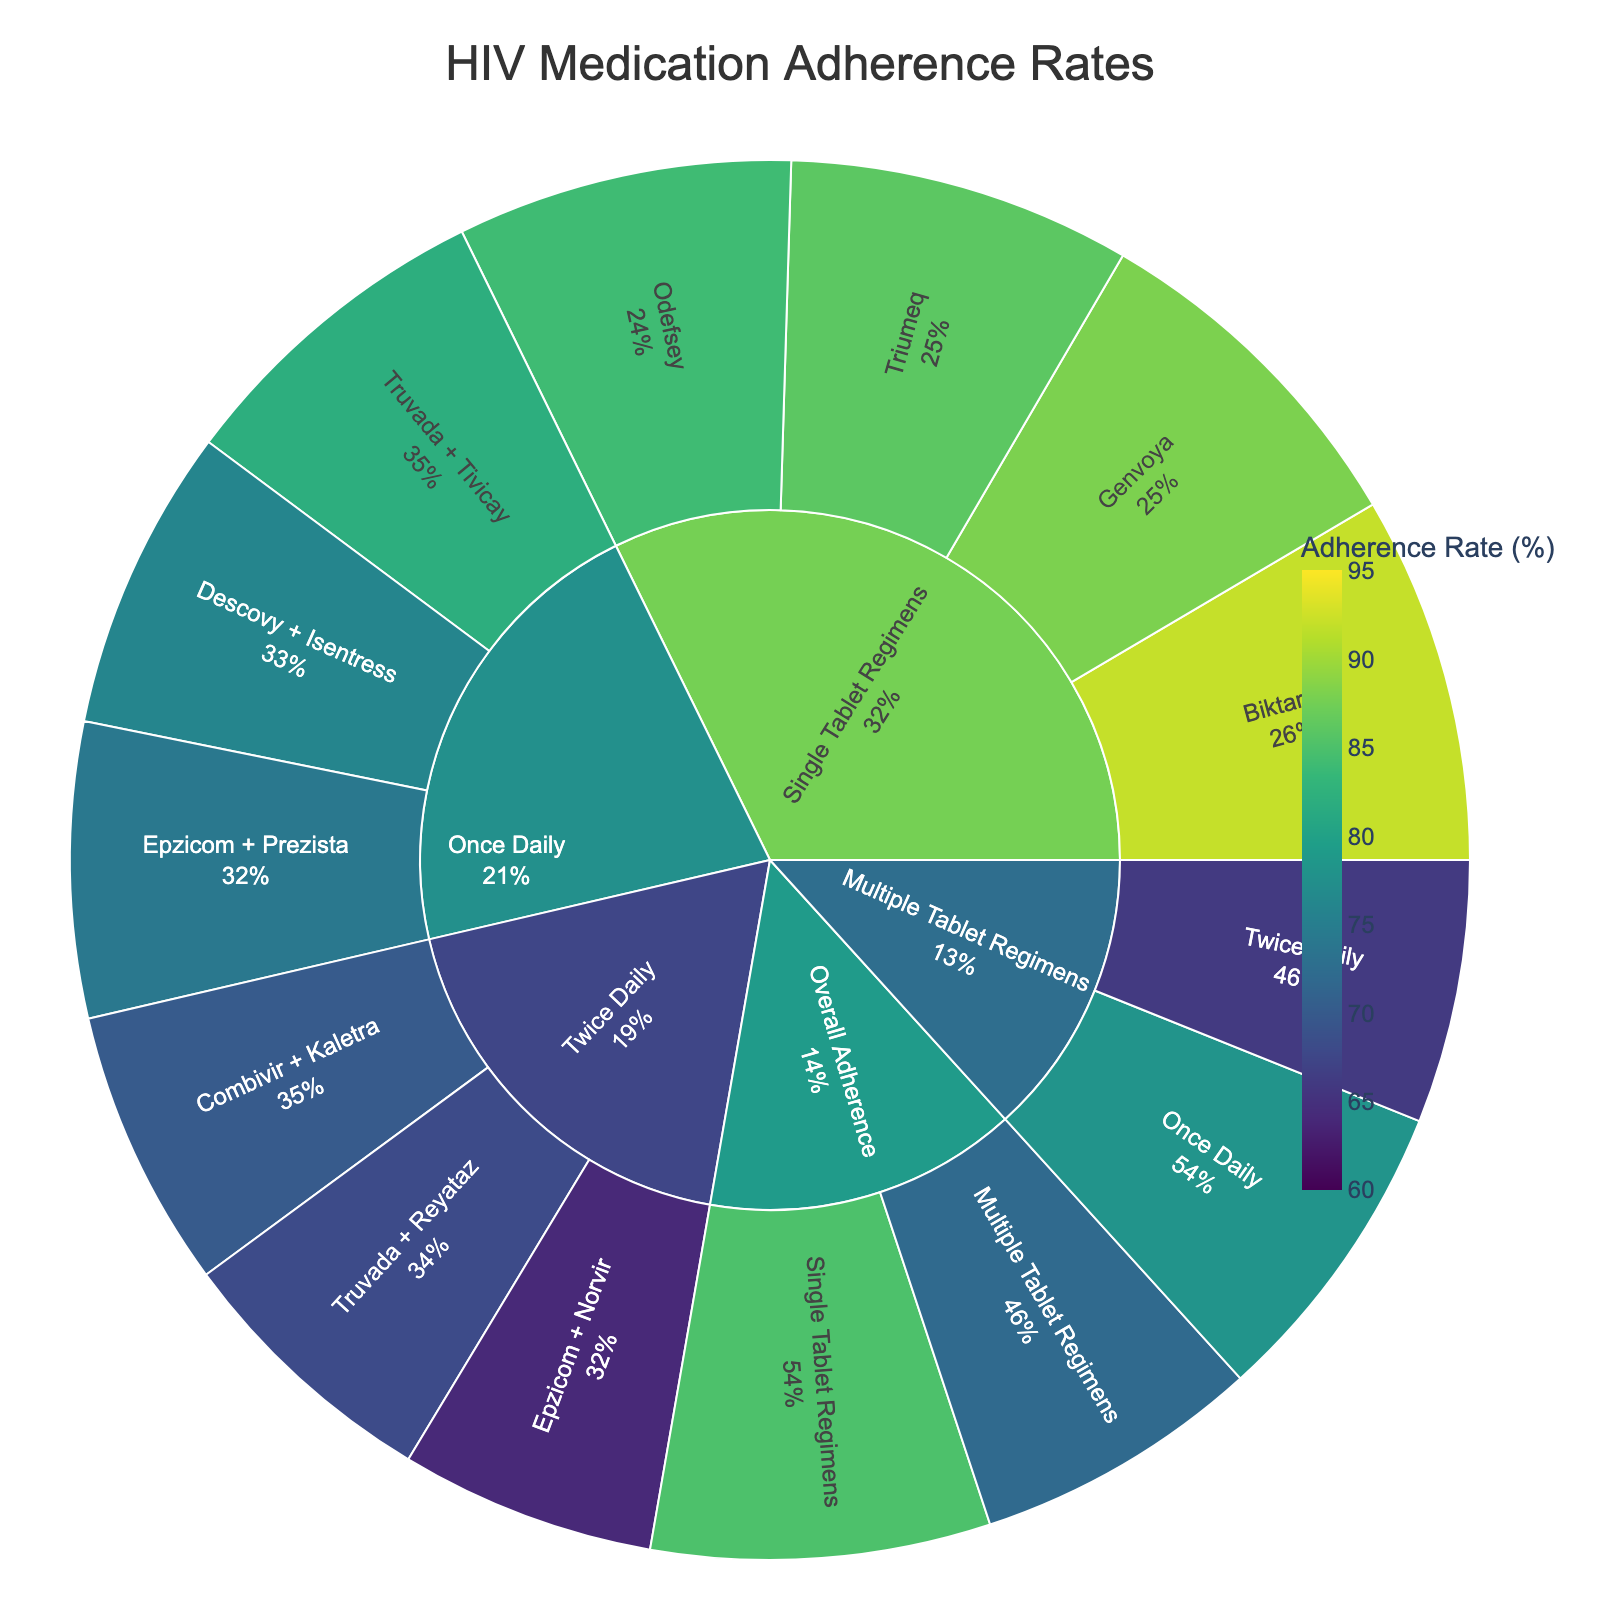What is the adherence rate for Single Tablet Regimens? The adherence rate for Single Tablet Regimens is shown directly within the category labeled "Single Tablet Regimens."
Answer: 85% Which drug under Single Tablet Regimens has the highest adherence rate? Under Single Tablet Regimens, the drug Biktarvy shows the highest percentage value at 92%.
Answer: Biktarvy Which group has a higher overall adherence rate, Single Tablet Regimens or Multiple Tablet Regimens? By looking at the adherence rates for Single Tablet Regimens (85%) and Multiple Tablet Regimens (72%), we see that Single Tablet Regimens have a higher overall adherence rate.
Answer: Single Tablet Regimens What is the adherence rate for Truvada + Tivicay under Once Daily? Truvada + Tivicay under Once Daily is located within the "Once Daily" subcategory, and the adherence rate for this combination is labeled as 82%.
Answer: 82% What is the sum of adherence rates for Once Daily regimens? Summing the adherence rates for Once Daily regimens: Truvada + Tivicay (82%), Descovy + Isentress (76%), Epzicom + Prezista (74%) results in 82 + 76 + 74 = 232.
Answer: 232% Which dosage frequency under Multiple Tablets Regimens has a lower adherence rate, Once Daily or Twice Daily? Comparing the adherence rates for Once Daily (78%) and Twice Daily (66%) under Multiple Tablets Regimens, Twice Daily has a lower adherence rate.
Answer: Twice Daily What is the difference in adherence rates between Triumeq and Odefsey under Single Tablet Regimens? Adherence rates for Triumeq and Odefsey are 86% and 84% respectively, so the difference is 86% - 84% = 2%.
Answer: 2% What percentage of the overall adherence rate does Genvoya contribute to Single Tablet Regimens? Genvoya has an adherence rate of 88%. Given that Single Tablet Regimens have an overall adherence rate of 85%, Genvoya's share within Single Tablet Regimens is calculated as (88 / 85) * 100 = 103.53%.
Answer: 103.53% Are all adherence rates for twice-daily Multiple Tablet Regimens lower than those for once-daily regimens? By comparing the adherence rates, Twice Daily regimens have rates of 70%, 68%, and 64%. The Once Daily rates are 82%, 76%, and 74%. All Twice Daily rates are indeed lower than those of the Once Daily regimens.
Answer: Yes 